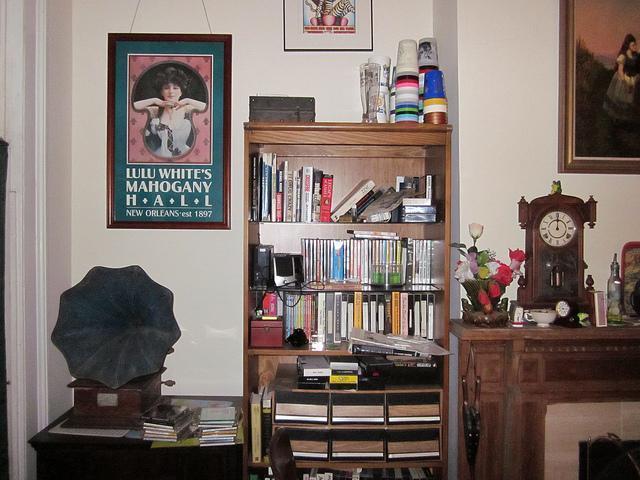How many books are in the photo?
Give a very brief answer. 2. 